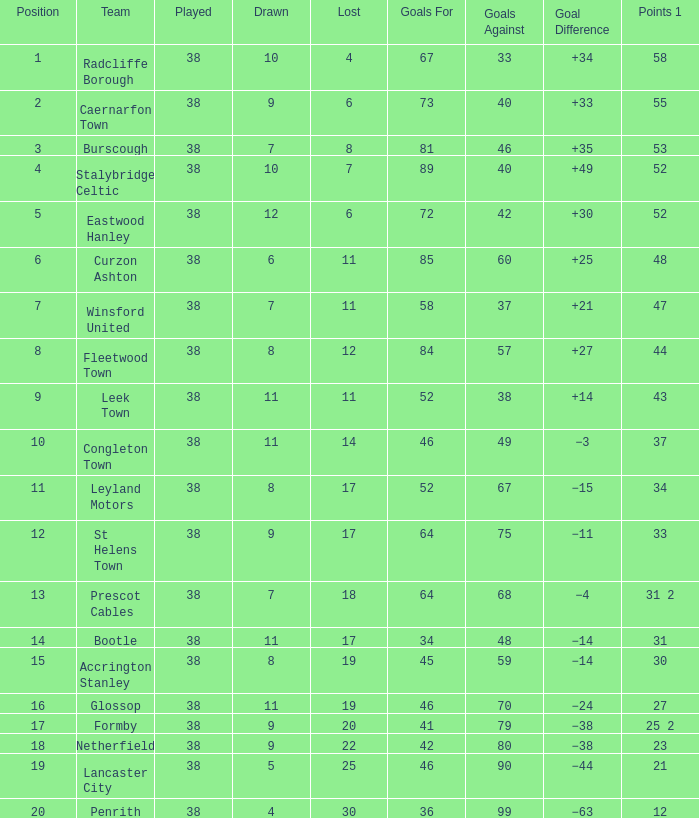Which team scored 46 goals and had less than 38 goals against them? None. 